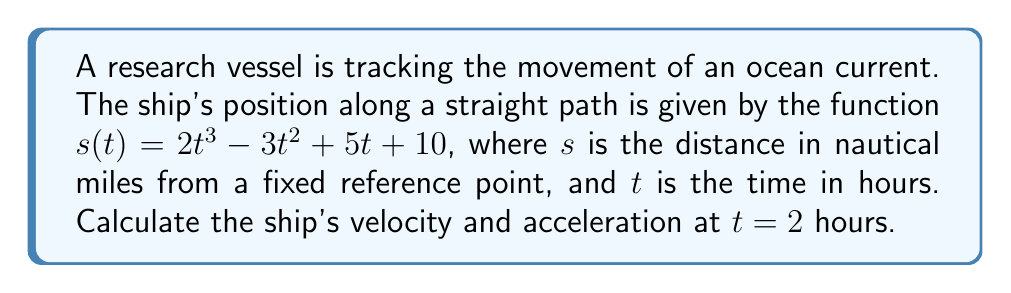Could you help me with this problem? To solve this problem, we need to follow these steps:

1. Find the velocity function by differentiating the position function:
   $$v(t) = \frac{ds}{dt} = 6t^2 - 6t + 5$$

2. Find the acceleration function by differentiating the velocity function:
   $$a(t) = \frac{dv}{dt} = 12t - 6$$

3. Calculate the velocity at $t = 2$ hours:
   $$v(2) = 6(2)^2 - 6(2) + 5 = 24 - 12 + 5 = 17$$

4. Calculate the acceleration at $t = 2$ hours:
   $$a(2) = 12(2) - 6 = 24 - 6 = 18$$

Therefore, at $t = 2$ hours:
- The ship's velocity is 17 nautical miles per hour
- The ship's acceleration is 18 nautical miles per hour squared
Answer: $v(2) = 17$ nautical miles/hour, $a(2) = 18$ nautical miles/hour² 